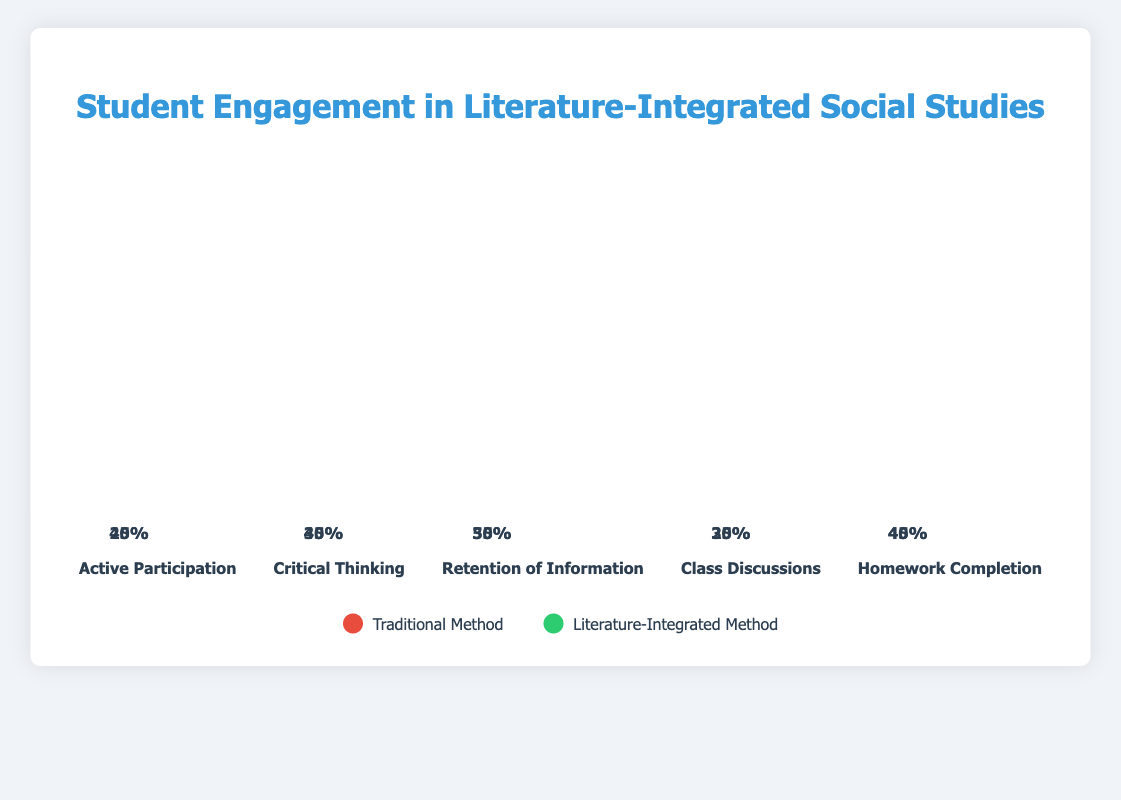What is the title of the figure? The title is usually shown at the top of the figure as a descriptive heading. In this case, "Student Engagement in Literature-Integrated Social Studies" is displayed at the top center of the figure, clearly indicating the subject of the chart.
Answer: Student Engagement in Literature-Integrated Social Studies What colors are used to represent the Traditional Method and the Literature-Integrated Method? The colors are indicated in the legend at the bottom of the figure. The Traditional Method is represented in red (#e74c3c) and the Literature-Integrated Method is in green (#2ecc71).
Answer: Red and green Which engagement metric shows the highest percentage for the Literature-Integrated Method? Look at the heights of the green bars for each metric. The highest green bar corresponds to "Retention of Information."
Answer: Retention of Information How much higher is Active Participation in the Literature-Integrated Method compared to the Traditional Method? Find the Active Participation metric. The Traditional Method shows 25%, and the Literature-Integrated Method shows 40%. The difference is 40% - 25%.
Answer: 15% What is the difference in Critical Thinking scores between the Traditional and Literature-Integrated Methods? For the Critical Thinking metric, the Traditional Method shows 30% and the Literature-Integrated Method shows 45%. The difference is 45% - 30%.
Answer: 15% Which method shows a lower percentage for Class Discussions? Compare the heights of the bars for Class Discussions. The Traditional Method shows 20%, and the Literature-Integrated Method shows 35%. The lower value is 20%.
Answer: Traditional Method How many metrics have a higher percentage in the Literature-Integrated Method than in the Traditional Method? Compare the values for each metric side-by-side. All metrics—Active Participation, Critical Thinking, Retention of Information, Class Discussions, Homework Completion—have higher percentages in the Literature-Integrated Method.
Answer: 5 What is the average engagement level for Retention of Information across both methods? Add the Retention of Information percentages for Traditional (35%) and Literature-Integrated (50%), then divide by 2 to find the average. (35% + 50%) / 2 = 42.5%
Answer: 42.5% By how much did Homework Completion increase in the Literature-Integrated Method? Compare the Homework Completion percentages: Traditional Method (40%) and Literature-Integrated Method (45%). The increase is 45% - 40%.
Answer: 5% 